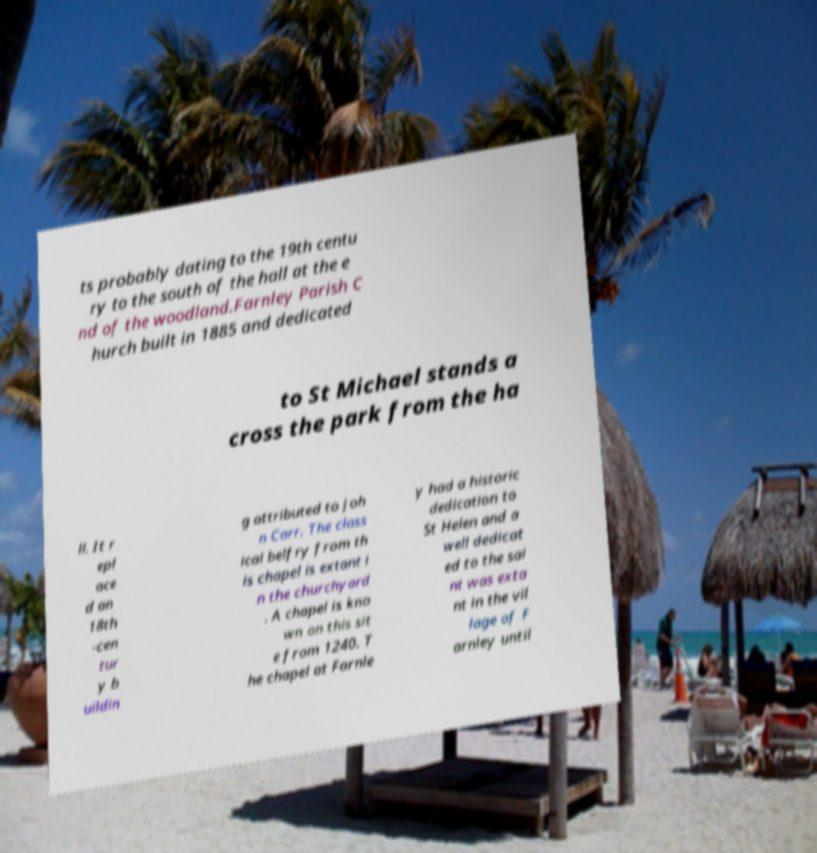Can you read and provide the text displayed in the image?This photo seems to have some interesting text. Can you extract and type it out for me? ts probably dating to the 19th centu ry to the south of the hall at the e nd of the woodland.Farnley Parish C hurch built in 1885 and dedicated to St Michael stands a cross the park from the ha ll. It r epl ace d an 18th -cen tur y b uildin g attributed to Joh n Carr. The class ical belfry from th is chapel is extant i n the churchyard . A chapel is kno wn on this sit e from 1240. T he chapel at Farnle y had a historic dedication to St Helen and a well dedicat ed to the sai nt was exta nt in the vil lage of F arnley until 